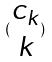<formula> <loc_0><loc_0><loc_500><loc_500>( \begin{matrix} c _ { k } \\ k \end{matrix} )</formula> 